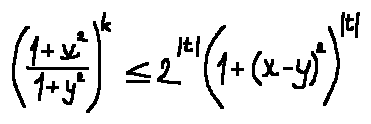Convert formula to latex. <formula><loc_0><loc_0><loc_500><loc_500>( \frac { 1 + x ^ { 2 } } { 1 + y ^ { 2 } } ) ^ { k } \leq 2 ^ { | t | } ( 1 + ( x - y ) ^ { 2 } ) ^ { | t | }</formula> 